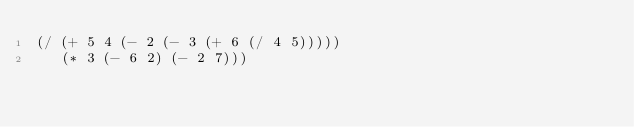<code> <loc_0><loc_0><loc_500><loc_500><_Scheme_>(/ (+ 5 4 (- 2 (- 3 (+ 6 (/ 4 5)))))
   (* 3 (- 6 2) (- 2 7)))

</code> 